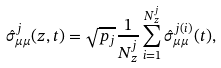Convert formula to latex. <formula><loc_0><loc_0><loc_500><loc_500>\hat { \sigma } _ { \mu \mu } ^ { j } ( z , t ) = \sqrt { p _ { j } } \frac { 1 } { N _ { z } ^ { j } } \sum _ { i = 1 } ^ { N _ { z } ^ { j } } \hat { \sigma } ^ { j ( i ) } _ { \mu \mu } ( t ) ,</formula> 